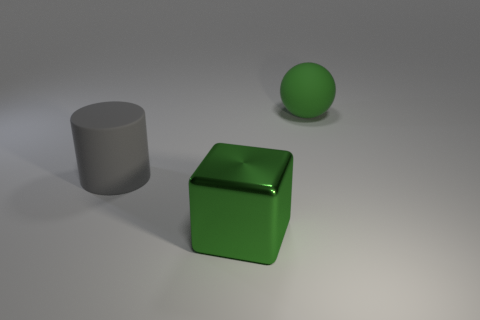Subtract 1 cubes. How many cubes are left? 0 Add 3 large gray metal cubes. How many objects exist? 6 Subtract all big rubber cylinders. Subtract all large gray objects. How many objects are left? 1 Add 3 big cubes. How many big cubes are left? 4 Add 3 large gray rubber things. How many large gray rubber things exist? 4 Subtract 0 gray blocks. How many objects are left? 3 Subtract all cylinders. How many objects are left? 2 Subtract all gray spheres. Subtract all purple cylinders. How many spheres are left? 1 